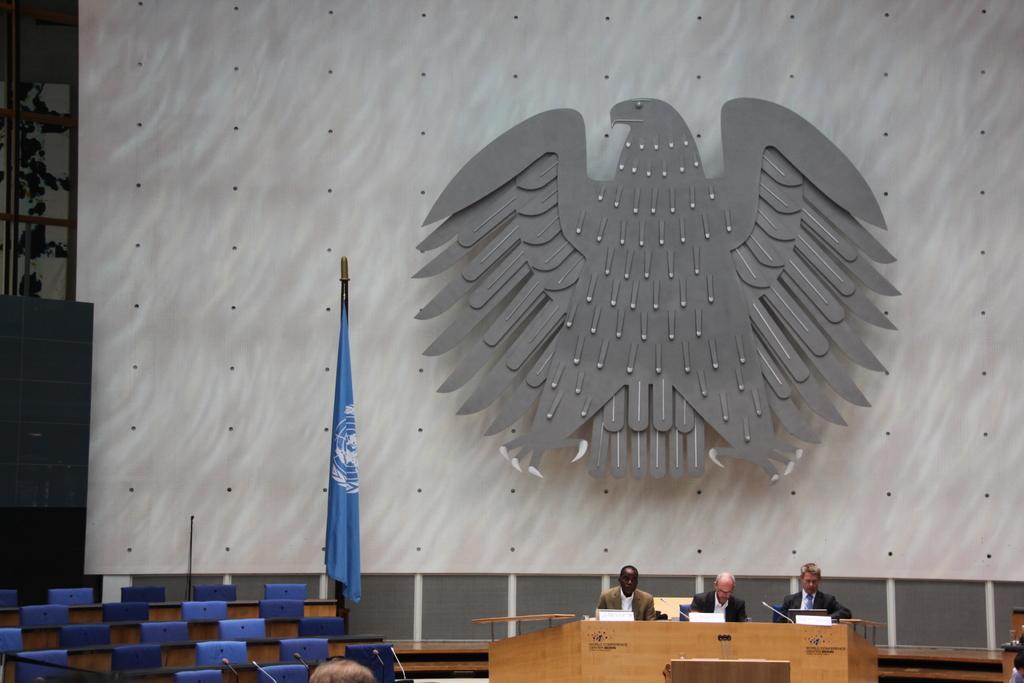Could you give a brief overview of what you see in this image? In this picture we can see three men are sitting in front of a desk, we can see a laptop, a microphone and boards present on the desk, at the left bottom there are some chairs, there is a flag in the middle, in the background we can see a replica of an eagle. 